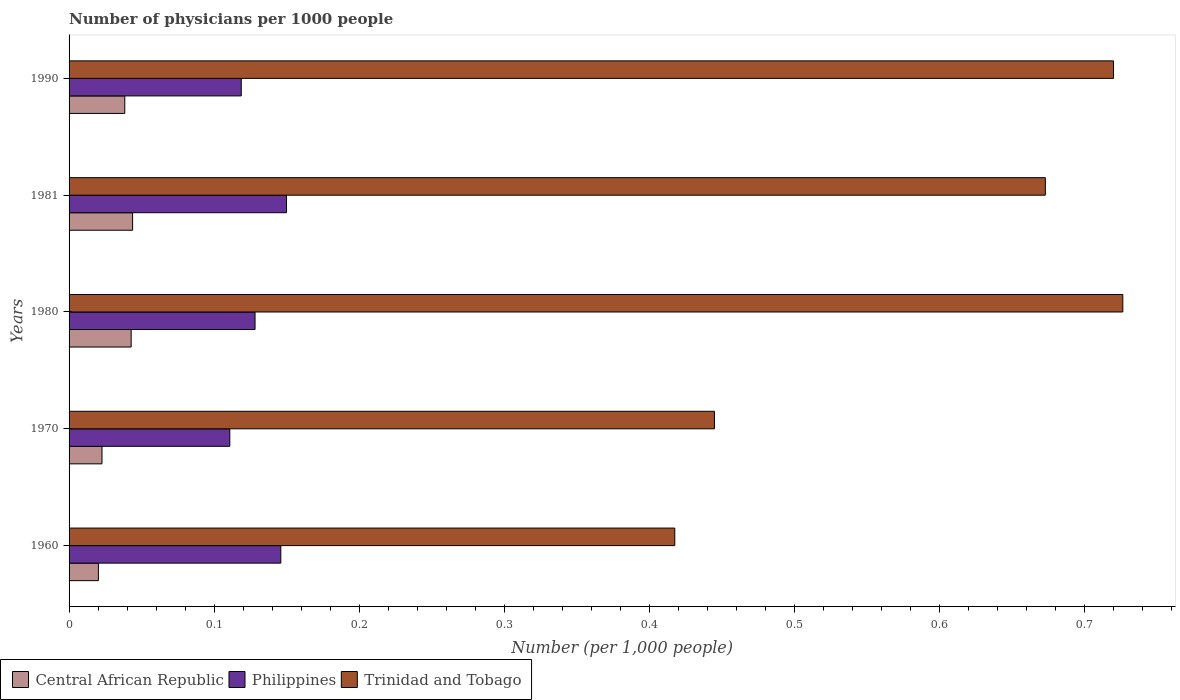How many different coloured bars are there?
Keep it short and to the point. 3. Are the number of bars per tick equal to the number of legend labels?
Provide a short and direct response. Yes. What is the number of physicians in Central African Republic in 1990?
Your answer should be very brief. 0.04. Across all years, what is the maximum number of physicians in Trinidad and Tobago?
Give a very brief answer. 0.73. Across all years, what is the minimum number of physicians in Central African Republic?
Provide a short and direct response. 0.02. In which year was the number of physicians in Philippines minimum?
Offer a very short reply. 1970. What is the total number of physicians in Trinidad and Tobago in the graph?
Give a very brief answer. 2.98. What is the difference between the number of physicians in Central African Republic in 1960 and that in 1970?
Provide a short and direct response. -0. What is the difference between the number of physicians in Trinidad and Tobago in 1970 and the number of physicians in Central African Republic in 1980?
Keep it short and to the point. 0.4. What is the average number of physicians in Trinidad and Tobago per year?
Ensure brevity in your answer.  0.6. In the year 1960, what is the difference between the number of physicians in Philippines and number of physicians in Trinidad and Tobago?
Offer a very short reply. -0.27. In how many years, is the number of physicians in Central African Republic greater than 0.7000000000000001 ?
Offer a very short reply. 0. What is the ratio of the number of physicians in Central African Republic in 1960 to that in 1980?
Your answer should be very brief. 0.47. Is the difference between the number of physicians in Philippines in 1960 and 1990 greater than the difference between the number of physicians in Trinidad and Tobago in 1960 and 1990?
Your answer should be compact. Yes. What is the difference between the highest and the second highest number of physicians in Trinidad and Tobago?
Provide a succinct answer. 0.01. What is the difference between the highest and the lowest number of physicians in Philippines?
Ensure brevity in your answer.  0.04. Is the sum of the number of physicians in Trinidad and Tobago in 1960 and 1970 greater than the maximum number of physicians in Philippines across all years?
Ensure brevity in your answer.  Yes. What does the 2nd bar from the top in 1981 represents?
Your answer should be very brief. Philippines. Is it the case that in every year, the sum of the number of physicians in Central African Republic and number of physicians in Trinidad and Tobago is greater than the number of physicians in Philippines?
Keep it short and to the point. Yes. How many bars are there?
Ensure brevity in your answer.  15. How many years are there in the graph?
Ensure brevity in your answer.  5. What is the difference between two consecutive major ticks on the X-axis?
Give a very brief answer. 0.1. Are the values on the major ticks of X-axis written in scientific E-notation?
Provide a succinct answer. No. Does the graph contain any zero values?
Your response must be concise. No. Does the graph contain grids?
Offer a very short reply. No. Where does the legend appear in the graph?
Your answer should be very brief. Bottom left. How many legend labels are there?
Give a very brief answer. 3. What is the title of the graph?
Your answer should be very brief. Number of physicians per 1000 people. What is the label or title of the X-axis?
Keep it short and to the point. Number (per 1,0 people). What is the label or title of the Y-axis?
Ensure brevity in your answer.  Years. What is the Number (per 1,000 people) of Central African Republic in 1960?
Give a very brief answer. 0.02. What is the Number (per 1,000 people) in Philippines in 1960?
Keep it short and to the point. 0.15. What is the Number (per 1,000 people) of Trinidad and Tobago in 1960?
Make the answer very short. 0.42. What is the Number (per 1,000 people) in Central African Republic in 1970?
Ensure brevity in your answer.  0.02. What is the Number (per 1,000 people) in Philippines in 1970?
Make the answer very short. 0.11. What is the Number (per 1,000 people) of Trinidad and Tobago in 1970?
Offer a very short reply. 0.44. What is the Number (per 1,000 people) in Central African Republic in 1980?
Provide a short and direct response. 0.04. What is the Number (per 1,000 people) of Philippines in 1980?
Your response must be concise. 0.13. What is the Number (per 1,000 people) of Trinidad and Tobago in 1980?
Offer a very short reply. 0.73. What is the Number (per 1,000 people) in Central African Republic in 1981?
Offer a very short reply. 0.04. What is the Number (per 1,000 people) in Philippines in 1981?
Make the answer very short. 0.15. What is the Number (per 1,000 people) of Trinidad and Tobago in 1981?
Give a very brief answer. 0.67. What is the Number (per 1,000 people) in Central African Republic in 1990?
Keep it short and to the point. 0.04. What is the Number (per 1,000 people) in Philippines in 1990?
Provide a succinct answer. 0.12. What is the Number (per 1,000 people) in Trinidad and Tobago in 1990?
Give a very brief answer. 0.72. Across all years, what is the maximum Number (per 1,000 people) in Central African Republic?
Provide a succinct answer. 0.04. Across all years, what is the maximum Number (per 1,000 people) of Philippines?
Give a very brief answer. 0.15. Across all years, what is the maximum Number (per 1,000 people) in Trinidad and Tobago?
Offer a terse response. 0.73. Across all years, what is the minimum Number (per 1,000 people) in Central African Republic?
Provide a succinct answer. 0.02. Across all years, what is the minimum Number (per 1,000 people) of Philippines?
Ensure brevity in your answer.  0.11. Across all years, what is the minimum Number (per 1,000 people) in Trinidad and Tobago?
Provide a short and direct response. 0.42. What is the total Number (per 1,000 people) in Central African Republic in the graph?
Make the answer very short. 0.17. What is the total Number (per 1,000 people) in Philippines in the graph?
Provide a short and direct response. 0.65. What is the total Number (per 1,000 people) of Trinidad and Tobago in the graph?
Keep it short and to the point. 2.98. What is the difference between the Number (per 1,000 people) of Central African Republic in 1960 and that in 1970?
Your response must be concise. -0. What is the difference between the Number (per 1,000 people) in Philippines in 1960 and that in 1970?
Your answer should be very brief. 0.04. What is the difference between the Number (per 1,000 people) of Trinidad and Tobago in 1960 and that in 1970?
Offer a very short reply. -0.03. What is the difference between the Number (per 1,000 people) of Central African Republic in 1960 and that in 1980?
Your answer should be compact. -0.02. What is the difference between the Number (per 1,000 people) of Philippines in 1960 and that in 1980?
Your response must be concise. 0.02. What is the difference between the Number (per 1,000 people) in Trinidad and Tobago in 1960 and that in 1980?
Ensure brevity in your answer.  -0.31. What is the difference between the Number (per 1,000 people) in Central African Republic in 1960 and that in 1981?
Give a very brief answer. -0.02. What is the difference between the Number (per 1,000 people) of Philippines in 1960 and that in 1981?
Your answer should be very brief. -0. What is the difference between the Number (per 1,000 people) in Trinidad and Tobago in 1960 and that in 1981?
Offer a very short reply. -0.26. What is the difference between the Number (per 1,000 people) of Central African Republic in 1960 and that in 1990?
Ensure brevity in your answer.  -0.02. What is the difference between the Number (per 1,000 people) in Philippines in 1960 and that in 1990?
Give a very brief answer. 0.03. What is the difference between the Number (per 1,000 people) in Trinidad and Tobago in 1960 and that in 1990?
Your response must be concise. -0.3. What is the difference between the Number (per 1,000 people) in Central African Republic in 1970 and that in 1980?
Your response must be concise. -0.02. What is the difference between the Number (per 1,000 people) of Philippines in 1970 and that in 1980?
Keep it short and to the point. -0.02. What is the difference between the Number (per 1,000 people) of Trinidad and Tobago in 1970 and that in 1980?
Your answer should be compact. -0.28. What is the difference between the Number (per 1,000 people) of Central African Republic in 1970 and that in 1981?
Ensure brevity in your answer.  -0.02. What is the difference between the Number (per 1,000 people) of Philippines in 1970 and that in 1981?
Provide a short and direct response. -0.04. What is the difference between the Number (per 1,000 people) in Trinidad and Tobago in 1970 and that in 1981?
Make the answer very short. -0.23. What is the difference between the Number (per 1,000 people) in Central African Republic in 1970 and that in 1990?
Make the answer very short. -0.02. What is the difference between the Number (per 1,000 people) of Philippines in 1970 and that in 1990?
Make the answer very short. -0.01. What is the difference between the Number (per 1,000 people) of Trinidad and Tobago in 1970 and that in 1990?
Make the answer very short. -0.28. What is the difference between the Number (per 1,000 people) in Central African Republic in 1980 and that in 1981?
Your response must be concise. -0. What is the difference between the Number (per 1,000 people) of Philippines in 1980 and that in 1981?
Keep it short and to the point. -0.02. What is the difference between the Number (per 1,000 people) in Trinidad and Tobago in 1980 and that in 1981?
Give a very brief answer. 0.05. What is the difference between the Number (per 1,000 people) of Central African Republic in 1980 and that in 1990?
Make the answer very short. 0. What is the difference between the Number (per 1,000 people) of Philippines in 1980 and that in 1990?
Your response must be concise. 0.01. What is the difference between the Number (per 1,000 people) in Trinidad and Tobago in 1980 and that in 1990?
Your response must be concise. 0.01. What is the difference between the Number (per 1,000 people) in Central African Republic in 1981 and that in 1990?
Your answer should be compact. 0.01. What is the difference between the Number (per 1,000 people) in Philippines in 1981 and that in 1990?
Your answer should be compact. 0.03. What is the difference between the Number (per 1,000 people) in Trinidad and Tobago in 1981 and that in 1990?
Your answer should be very brief. -0.05. What is the difference between the Number (per 1,000 people) in Central African Republic in 1960 and the Number (per 1,000 people) in Philippines in 1970?
Offer a terse response. -0.09. What is the difference between the Number (per 1,000 people) of Central African Republic in 1960 and the Number (per 1,000 people) of Trinidad and Tobago in 1970?
Provide a short and direct response. -0.42. What is the difference between the Number (per 1,000 people) in Philippines in 1960 and the Number (per 1,000 people) in Trinidad and Tobago in 1970?
Your answer should be very brief. -0.3. What is the difference between the Number (per 1,000 people) of Central African Republic in 1960 and the Number (per 1,000 people) of Philippines in 1980?
Provide a short and direct response. -0.11. What is the difference between the Number (per 1,000 people) of Central African Republic in 1960 and the Number (per 1,000 people) of Trinidad and Tobago in 1980?
Provide a succinct answer. -0.71. What is the difference between the Number (per 1,000 people) in Philippines in 1960 and the Number (per 1,000 people) in Trinidad and Tobago in 1980?
Provide a short and direct response. -0.58. What is the difference between the Number (per 1,000 people) of Central African Republic in 1960 and the Number (per 1,000 people) of Philippines in 1981?
Offer a very short reply. -0.13. What is the difference between the Number (per 1,000 people) of Central African Republic in 1960 and the Number (per 1,000 people) of Trinidad and Tobago in 1981?
Your answer should be compact. -0.65. What is the difference between the Number (per 1,000 people) of Philippines in 1960 and the Number (per 1,000 people) of Trinidad and Tobago in 1981?
Offer a terse response. -0.53. What is the difference between the Number (per 1,000 people) in Central African Republic in 1960 and the Number (per 1,000 people) in Philippines in 1990?
Provide a succinct answer. -0.1. What is the difference between the Number (per 1,000 people) in Central African Republic in 1960 and the Number (per 1,000 people) in Trinidad and Tobago in 1990?
Offer a very short reply. -0.7. What is the difference between the Number (per 1,000 people) of Philippines in 1960 and the Number (per 1,000 people) of Trinidad and Tobago in 1990?
Make the answer very short. -0.57. What is the difference between the Number (per 1,000 people) of Central African Republic in 1970 and the Number (per 1,000 people) of Philippines in 1980?
Your response must be concise. -0.11. What is the difference between the Number (per 1,000 people) of Central African Republic in 1970 and the Number (per 1,000 people) of Trinidad and Tobago in 1980?
Your answer should be very brief. -0.7. What is the difference between the Number (per 1,000 people) in Philippines in 1970 and the Number (per 1,000 people) in Trinidad and Tobago in 1980?
Offer a very short reply. -0.62. What is the difference between the Number (per 1,000 people) of Central African Republic in 1970 and the Number (per 1,000 people) of Philippines in 1981?
Your answer should be very brief. -0.13. What is the difference between the Number (per 1,000 people) in Central African Republic in 1970 and the Number (per 1,000 people) in Trinidad and Tobago in 1981?
Offer a terse response. -0.65. What is the difference between the Number (per 1,000 people) of Philippines in 1970 and the Number (per 1,000 people) of Trinidad and Tobago in 1981?
Your answer should be very brief. -0.56. What is the difference between the Number (per 1,000 people) in Central African Republic in 1970 and the Number (per 1,000 people) in Philippines in 1990?
Ensure brevity in your answer.  -0.1. What is the difference between the Number (per 1,000 people) of Central African Republic in 1970 and the Number (per 1,000 people) of Trinidad and Tobago in 1990?
Offer a very short reply. -0.7. What is the difference between the Number (per 1,000 people) of Philippines in 1970 and the Number (per 1,000 people) of Trinidad and Tobago in 1990?
Ensure brevity in your answer.  -0.61. What is the difference between the Number (per 1,000 people) of Central African Republic in 1980 and the Number (per 1,000 people) of Philippines in 1981?
Keep it short and to the point. -0.11. What is the difference between the Number (per 1,000 people) in Central African Republic in 1980 and the Number (per 1,000 people) in Trinidad and Tobago in 1981?
Provide a succinct answer. -0.63. What is the difference between the Number (per 1,000 people) of Philippines in 1980 and the Number (per 1,000 people) of Trinidad and Tobago in 1981?
Provide a succinct answer. -0.54. What is the difference between the Number (per 1,000 people) in Central African Republic in 1980 and the Number (per 1,000 people) in Philippines in 1990?
Your answer should be very brief. -0.08. What is the difference between the Number (per 1,000 people) in Central African Republic in 1980 and the Number (per 1,000 people) in Trinidad and Tobago in 1990?
Offer a very short reply. -0.68. What is the difference between the Number (per 1,000 people) in Philippines in 1980 and the Number (per 1,000 people) in Trinidad and Tobago in 1990?
Your response must be concise. -0.59. What is the difference between the Number (per 1,000 people) in Central African Republic in 1981 and the Number (per 1,000 people) in Philippines in 1990?
Offer a very short reply. -0.07. What is the difference between the Number (per 1,000 people) in Central African Republic in 1981 and the Number (per 1,000 people) in Trinidad and Tobago in 1990?
Your answer should be very brief. -0.68. What is the difference between the Number (per 1,000 people) of Philippines in 1981 and the Number (per 1,000 people) of Trinidad and Tobago in 1990?
Provide a succinct answer. -0.57. What is the average Number (per 1,000 people) of Central African Republic per year?
Make the answer very short. 0.03. What is the average Number (per 1,000 people) of Philippines per year?
Keep it short and to the point. 0.13. What is the average Number (per 1,000 people) in Trinidad and Tobago per year?
Ensure brevity in your answer.  0.6. In the year 1960, what is the difference between the Number (per 1,000 people) of Central African Republic and Number (per 1,000 people) of Philippines?
Provide a succinct answer. -0.13. In the year 1960, what is the difference between the Number (per 1,000 people) of Central African Republic and Number (per 1,000 people) of Trinidad and Tobago?
Offer a terse response. -0.4. In the year 1960, what is the difference between the Number (per 1,000 people) of Philippines and Number (per 1,000 people) of Trinidad and Tobago?
Give a very brief answer. -0.27. In the year 1970, what is the difference between the Number (per 1,000 people) of Central African Republic and Number (per 1,000 people) of Philippines?
Your answer should be very brief. -0.09. In the year 1970, what is the difference between the Number (per 1,000 people) of Central African Republic and Number (per 1,000 people) of Trinidad and Tobago?
Provide a short and direct response. -0.42. In the year 1970, what is the difference between the Number (per 1,000 people) of Philippines and Number (per 1,000 people) of Trinidad and Tobago?
Give a very brief answer. -0.33. In the year 1980, what is the difference between the Number (per 1,000 people) in Central African Republic and Number (per 1,000 people) in Philippines?
Your answer should be compact. -0.09. In the year 1980, what is the difference between the Number (per 1,000 people) in Central African Republic and Number (per 1,000 people) in Trinidad and Tobago?
Provide a short and direct response. -0.68. In the year 1980, what is the difference between the Number (per 1,000 people) of Philippines and Number (per 1,000 people) of Trinidad and Tobago?
Provide a short and direct response. -0.6. In the year 1981, what is the difference between the Number (per 1,000 people) in Central African Republic and Number (per 1,000 people) in Philippines?
Offer a terse response. -0.11. In the year 1981, what is the difference between the Number (per 1,000 people) of Central African Republic and Number (per 1,000 people) of Trinidad and Tobago?
Offer a terse response. -0.63. In the year 1981, what is the difference between the Number (per 1,000 people) in Philippines and Number (per 1,000 people) in Trinidad and Tobago?
Provide a succinct answer. -0.52. In the year 1990, what is the difference between the Number (per 1,000 people) of Central African Republic and Number (per 1,000 people) of Philippines?
Give a very brief answer. -0.08. In the year 1990, what is the difference between the Number (per 1,000 people) in Central African Republic and Number (per 1,000 people) in Trinidad and Tobago?
Keep it short and to the point. -0.68. In the year 1990, what is the difference between the Number (per 1,000 people) of Philippines and Number (per 1,000 people) of Trinidad and Tobago?
Keep it short and to the point. -0.6. What is the ratio of the Number (per 1,000 people) of Central African Republic in 1960 to that in 1970?
Offer a terse response. 0.89. What is the ratio of the Number (per 1,000 people) in Philippines in 1960 to that in 1970?
Your response must be concise. 1.32. What is the ratio of the Number (per 1,000 people) in Trinidad and Tobago in 1960 to that in 1970?
Your answer should be compact. 0.94. What is the ratio of the Number (per 1,000 people) of Central African Republic in 1960 to that in 1980?
Make the answer very short. 0.47. What is the ratio of the Number (per 1,000 people) of Philippines in 1960 to that in 1980?
Your response must be concise. 1.14. What is the ratio of the Number (per 1,000 people) of Trinidad and Tobago in 1960 to that in 1980?
Keep it short and to the point. 0.57. What is the ratio of the Number (per 1,000 people) in Central African Republic in 1960 to that in 1981?
Make the answer very short. 0.46. What is the ratio of the Number (per 1,000 people) of Philippines in 1960 to that in 1981?
Make the answer very short. 0.97. What is the ratio of the Number (per 1,000 people) in Trinidad and Tobago in 1960 to that in 1981?
Offer a terse response. 0.62. What is the ratio of the Number (per 1,000 people) in Central African Republic in 1960 to that in 1990?
Your answer should be very brief. 0.53. What is the ratio of the Number (per 1,000 people) in Philippines in 1960 to that in 1990?
Ensure brevity in your answer.  1.23. What is the ratio of the Number (per 1,000 people) of Trinidad and Tobago in 1960 to that in 1990?
Your answer should be compact. 0.58. What is the ratio of the Number (per 1,000 people) in Central African Republic in 1970 to that in 1980?
Offer a very short reply. 0.53. What is the ratio of the Number (per 1,000 people) of Philippines in 1970 to that in 1980?
Make the answer very short. 0.86. What is the ratio of the Number (per 1,000 people) of Trinidad and Tobago in 1970 to that in 1980?
Offer a terse response. 0.61. What is the ratio of the Number (per 1,000 people) in Central African Republic in 1970 to that in 1981?
Your response must be concise. 0.52. What is the ratio of the Number (per 1,000 people) of Philippines in 1970 to that in 1981?
Give a very brief answer. 0.74. What is the ratio of the Number (per 1,000 people) in Trinidad and Tobago in 1970 to that in 1981?
Provide a short and direct response. 0.66. What is the ratio of the Number (per 1,000 people) of Central African Republic in 1970 to that in 1990?
Your response must be concise. 0.59. What is the ratio of the Number (per 1,000 people) in Philippines in 1970 to that in 1990?
Give a very brief answer. 0.93. What is the ratio of the Number (per 1,000 people) in Trinidad and Tobago in 1970 to that in 1990?
Keep it short and to the point. 0.62. What is the ratio of the Number (per 1,000 people) of Central African Republic in 1980 to that in 1981?
Make the answer very short. 0.98. What is the ratio of the Number (per 1,000 people) in Philippines in 1980 to that in 1981?
Provide a short and direct response. 0.86. What is the ratio of the Number (per 1,000 people) in Trinidad and Tobago in 1980 to that in 1981?
Keep it short and to the point. 1.08. What is the ratio of the Number (per 1,000 people) in Central African Republic in 1980 to that in 1990?
Keep it short and to the point. 1.11. What is the ratio of the Number (per 1,000 people) in Philippines in 1980 to that in 1990?
Provide a succinct answer. 1.08. What is the ratio of the Number (per 1,000 people) of Trinidad and Tobago in 1980 to that in 1990?
Give a very brief answer. 1.01. What is the ratio of the Number (per 1,000 people) of Central African Republic in 1981 to that in 1990?
Provide a succinct answer. 1.14. What is the ratio of the Number (per 1,000 people) of Philippines in 1981 to that in 1990?
Make the answer very short. 1.26. What is the ratio of the Number (per 1,000 people) in Trinidad and Tobago in 1981 to that in 1990?
Offer a very short reply. 0.93. What is the difference between the highest and the second highest Number (per 1,000 people) of Philippines?
Provide a succinct answer. 0. What is the difference between the highest and the second highest Number (per 1,000 people) of Trinidad and Tobago?
Make the answer very short. 0.01. What is the difference between the highest and the lowest Number (per 1,000 people) in Central African Republic?
Your answer should be very brief. 0.02. What is the difference between the highest and the lowest Number (per 1,000 people) of Philippines?
Provide a succinct answer. 0.04. What is the difference between the highest and the lowest Number (per 1,000 people) in Trinidad and Tobago?
Provide a short and direct response. 0.31. 